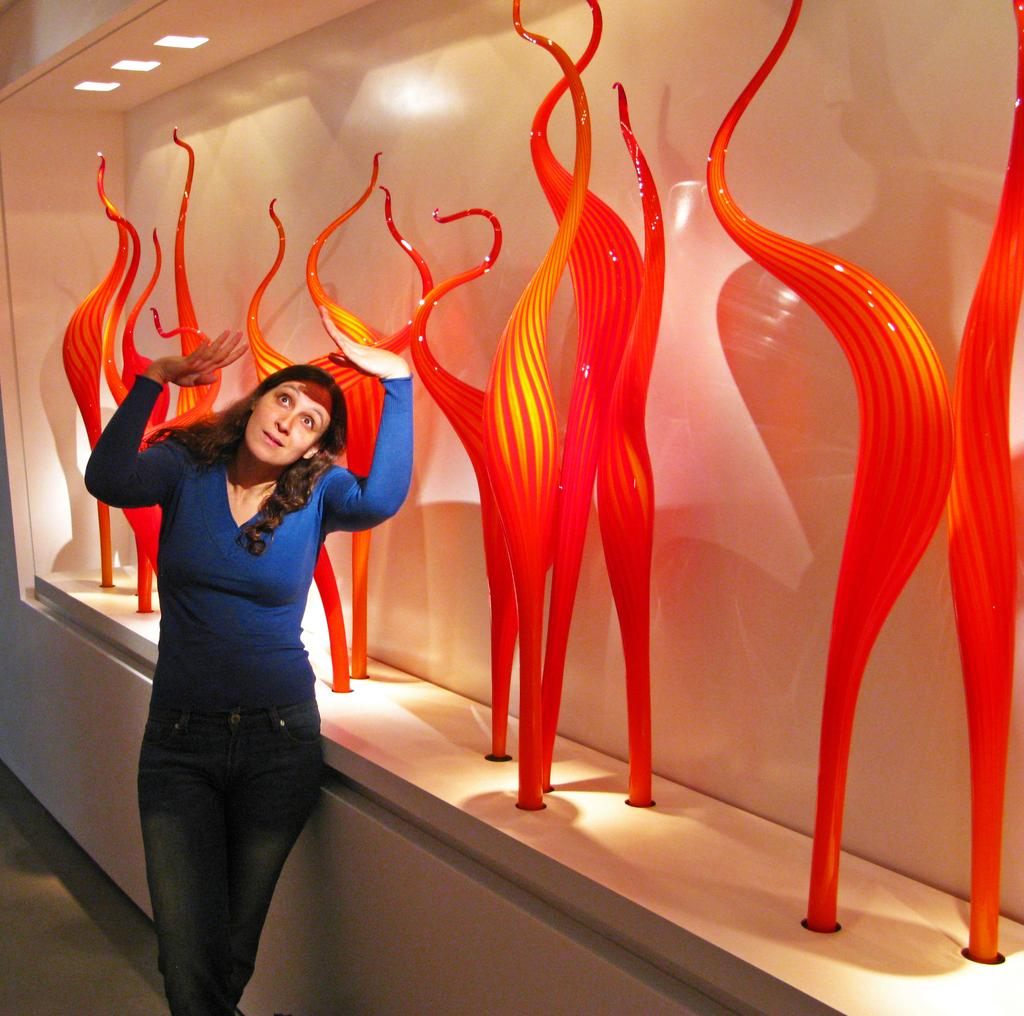What is the main subject of the image? There is a woman standing in the image. What is the woman wearing? The woman is wearing clothes. What colors can be seen in the objects in the image? There are objects with dark orange and yellow colors in the image. What type of surface is visible in the image? The image shows a floor. What can be seen providing illumination in the image? There are lights visible in the image. What type of wine is the woman holding in the image? There is no wine present in the image; the woman is not holding any wine. Can you tell me where the son is sleeping in the image? There is no mention of a son or a bedroom in the image, so it is not possible to determine where a son might be sleeping. 